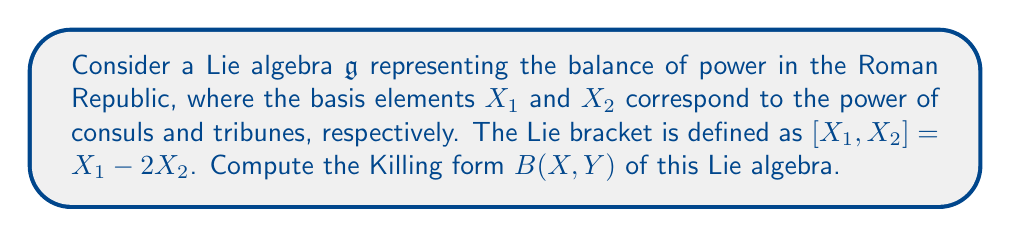Give your solution to this math problem. To compute the Killing form of this Lie algebra, we need to follow these steps:

1) The Killing form is defined as $B(X,Y) = \text{tr}(\text{ad}_X \circ \text{ad}_Y)$, where $\text{ad}_X$ is the adjoint representation of $X$.

2) First, we need to find the matrix representations of $\text{ad}_{X_1}$ and $\text{ad}_{X_2}$:

   $\text{ad}_{X_1}(X_1) = [X_1, X_1] = 0$
   $\text{ad}_{X_1}(X_2) = [X_1, X_2] = X_1 - 2X_2$

   So, $\text{ad}_{X_1}$ in matrix form is:
   $$\text{ad}_{X_1} = \begin{pmatrix} 0 & 1 \\ 0 & -2 \end{pmatrix}$$

   $\text{ad}_{X_2}(X_1) = [X_2, X_1] = -[X_1, X_2] = -X_1 + 2X_2$
   $\text{ad}_{X_2}(X_2) = [X_2, X_2] = 0$

   So, $\text{ad}_{X_2}$ in matrix form is:
   $$\text{ad}_{X_2} = \begin{pmatrix} -1 & 0 \\ 2 & 0 \end{pmatrix}$$

3) Now, we can compute $B(X_1, X_1)$, $B(X_1, X_2)$, $B(X_2, X_1)$, and $B(X_2, X_2)$:

   $B(X_1, X_1) = \text{tr}(\text{ad}_{X_1} \circ \text{ad}_{X_1}) = \text{tr}\begin{pmatrix} 0 & 1 \\ 0 & -2 \end{pmatrix}\begin{pmatrix} 0 & 1 \\ 0 & -2 \end{pmatrix} = \text{tr}\begin{pmatrix} 0 & -2 \\ 0 & 4 \end{pmatrix} = 4$

   $B(X_1, X_2) = \text{tr}(\text{ad}_{X_1} \circ \text{ad}_{X_2}) = \text{tr}\begin{pmatrix} 0 & 1 \\ 0 & -2 \end{pmatrix}\begin{pmatrix} -1 & 0 \\ 2 & 0 \end{pmatrix} = \text{tr}\begin{pmatrix} 2 & 0 \\ -4 & 0 \end{pmatrix} = 2$

   $B(X_2, X_1) = \text{tr}(\text{ad}_{X_2} \circ \text{ad}_{X_1}) = \text{tr}\begin{pmatrix} -1 & 0 \\ 2 & 0 \end{pmatrix}\begin{pmatrix} 0 & 1 \\ 0 & -2 \end{pmatrix} = \text{tr}\begin{pmatrix} 0 & -1 \\ 0 & -4 \end{pmatrix} = -4$

   $B(X_2, X_2) = \text{tr}(\text{ad}_{X_2} \circ \text{ad}_{X_2}) = \text{tr}\begin{pmatrix} -1 & 0 \\ 2 & 0 \end{pmatrix}\begin{pmatrix} -1 & 0 \\ 2 & 0 \end{pmatrix} = \text{tr}\begin{pmatrix} 1 & 0 \\ -2 & 0 \end{pmatrix} = 1$

4) Therefore, the Killing form can be represented as a matrix:

   $$B = \begin{pmatrix} 4 & 2 \\ -4 & 1 \end{pmatrix}$$

This matrix represents the Killing form of the Lie algebra describing the balance of power between consuls and tribunes.
Answer: The Killing form of the given Lie algebra is:

$$B = \begin{pmatrix} 4 & 2 \\ -4 & 1 \end{pmatrix}$$ 